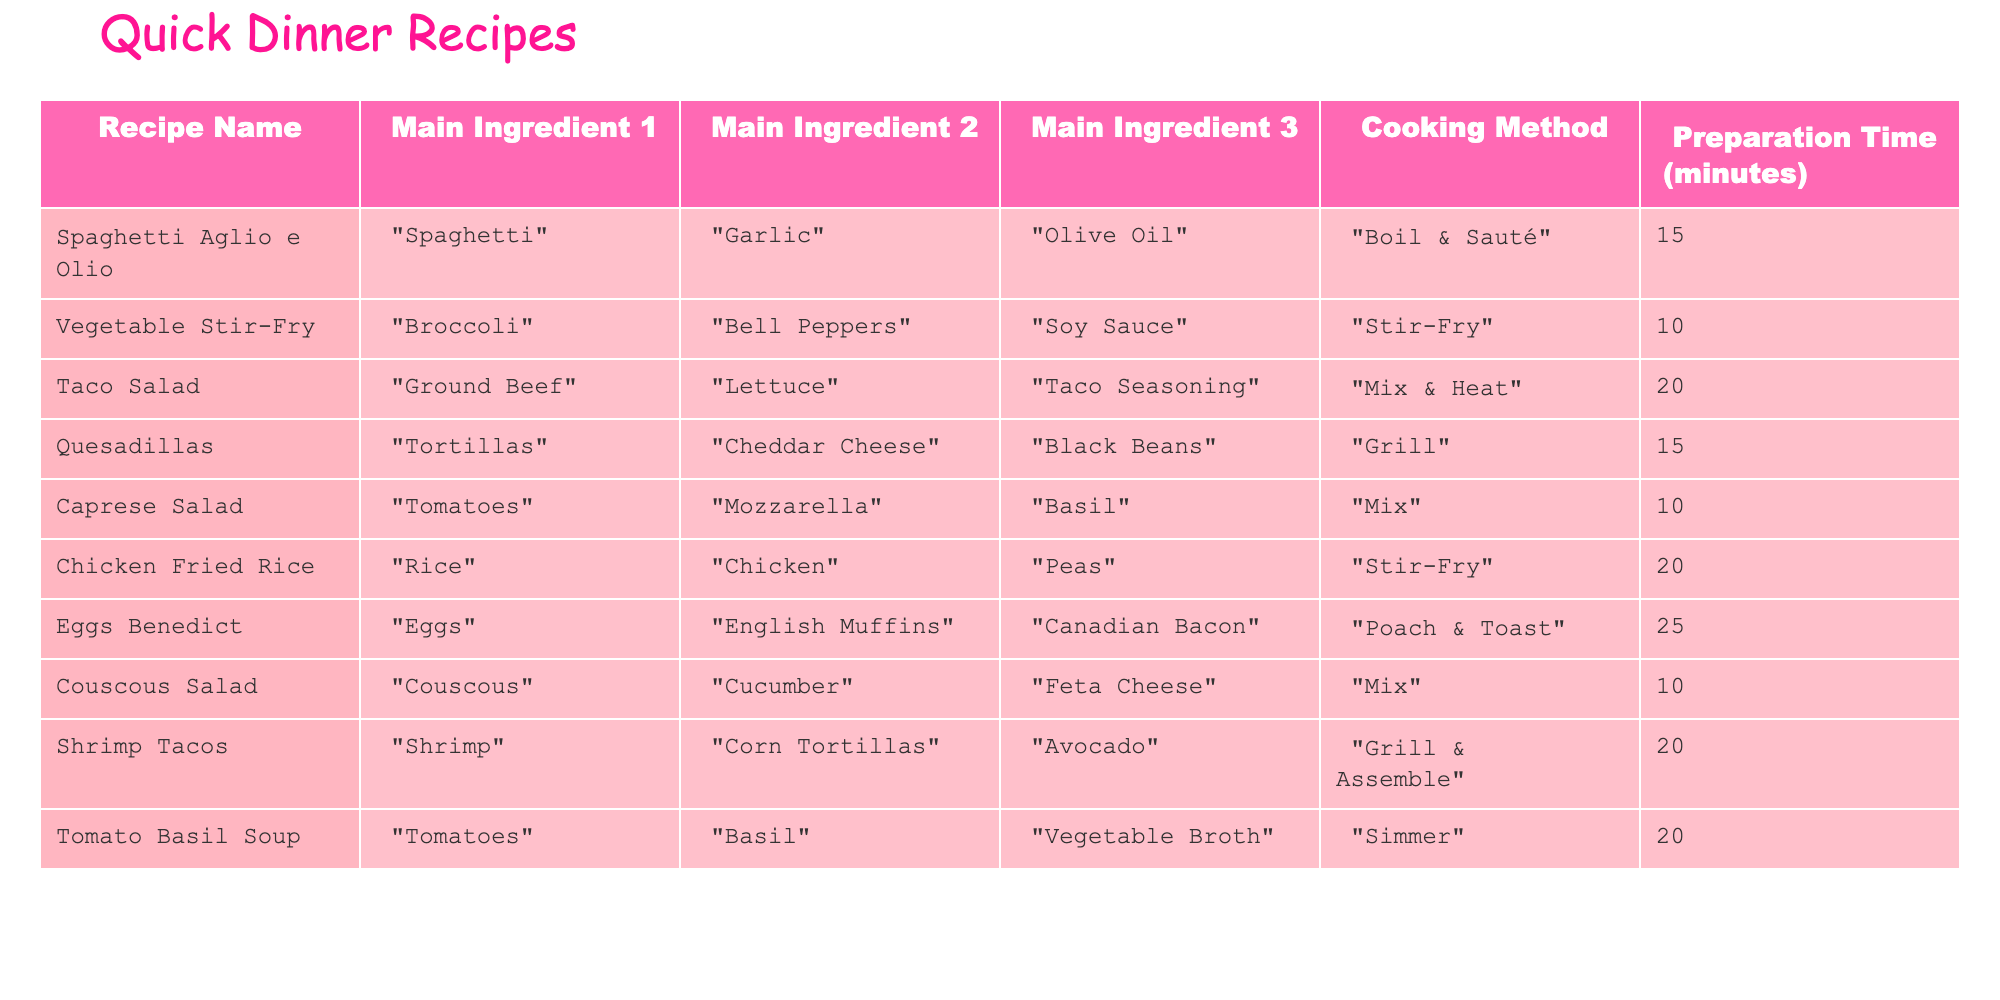What is the main ingredient for Spaghetti Aglio e Olio? The table shows that the main ingredient for Spaghetti Aglio e Olio is Spaghetti.
Answer: Spaghetti How long does it take to prepare Taco Salad? According to the table, Taco Salad has a preparation time of 20 minutes.
Answer: 20 minutes Is there any recipe that requires less than 10 minutes to prepare? Looking at the table, there are no recipes that have a preparation time of less than 10 minutes. Hence, the answer is no.
Answer: No Which recipe has the shortest preparation time? From the table, Vegetable Stir-Fry and Caprese Salad both have a preparation time of 10 minutes, which is the shortest time listed.
Answer: Vegetable Stir-Fry and Caprese Salad What is the total preparation time for all recipes? Adding the preparation times together: 15 + 10 + 20 + 15 + 10 + 20 + 25 + 10 + 20 + 20 gives a total of 15 + 10 = 25, 25 + 20 = 45, 45 + 15 = 60, 60 + 10 = 70, 70 + 20 = 90, 90 + 25 = 115, 115 + 10 = 125, 125 + 20 = 145, and finally 145 + 20 = 165 minutes. The total preparation time is therefore 165 minutes.
Answer: 165 minutes How many recipes involve grilling? The table lists Quesadillas and Shrimp Tacos as recipes that involve grilling, which makes a total of 2 recipes.
Answer: 2 recipes Which recipe has chicken as a main ingredient, and what is its cooking method? The table shows that Chicken Fried Rice has chicken as a main ingredient and is cooked using stir-fry.
Answer: Chicken Fried Rice; Stir-Fry Are there more recipes that require mixing or grilling? The table shows a total of 3 recipes that require grilling (Quesadillas, Shrimp Tacos) and 4 recipes that require mixing (Taco Salad, Caprese Salad, Couscous Salad). So, there are indeed more recipes that require mixing.
Answer: Yes 